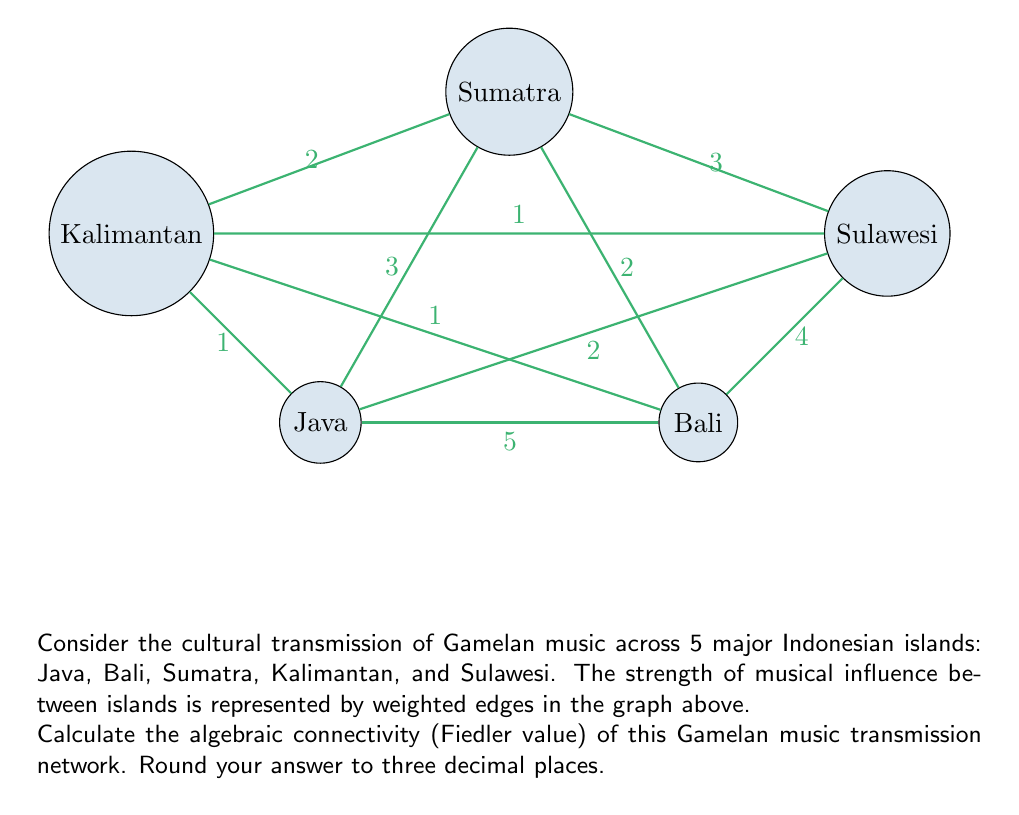Show me your answer to this math problem. To find the algebraic connectivity, we need to follow these steps:

1) First, construct the Laplacian matrix $L$ of the graph:
   $$L = D - A$$
   where $D$ is the degree matrix and $A$ is the adjacency matrix.

2) The degree matrix $D$ is:
   $$D = \begin{bmatrix}
   12 & 0 & 0 & 0 & 0 \\
   0 & 12 & 0 & 0 & 0 \\
   0 & 0 & 10 & 0 & 0 \\
   0 & 0 & 0 & 4 & 0 \\
   0 & 0 & 0 & 0 & 10
   \end{bmatrix}$$

3) The adjacency matrix $A$ is:
   $$A = \begin{bmatrix}
   0 & 5 & 3 & 1 & 2 \\
   5 & 0 & 2 & 1 & 4 \\
   3 & 2 & 0 & 2 & 3 \\
   1 & 1 & 2 & 0 & 1 \\
   2 & 4 & 3 & 1 & 0
   \end{bmatrix}$$

4) Calculate the Laplacian matrix:
   $$L = D - A = \begin{bmatrix}
   12 & -5 & -3 & -1 & -2 \\
   -5 & 12 & -2 & -1 & -4 \\
   -3 & -2 & 10 & -2 & -3 \\
   -1 & -1 & -2 & 4 & -1 \\
   -2 & -4 & -3 & -1 & 10
   \end{bmatrix}$$

5) Find the eigenvalues of $L$. This can be done using numerical methods or specialized software.

6) The algebraic connectivity is the second smallest eigenvalue of $L$.

Using a computer algebra system, we find that the eigenvalues of $L$ are approximately:
0, 2.382, 8.249, 15.184, and 22.185

The second smallest eigenvalue (Fiedler value) is approximately 2.382.

Rounding to three decimal places gives us 2.382.
Answer: 2.382 